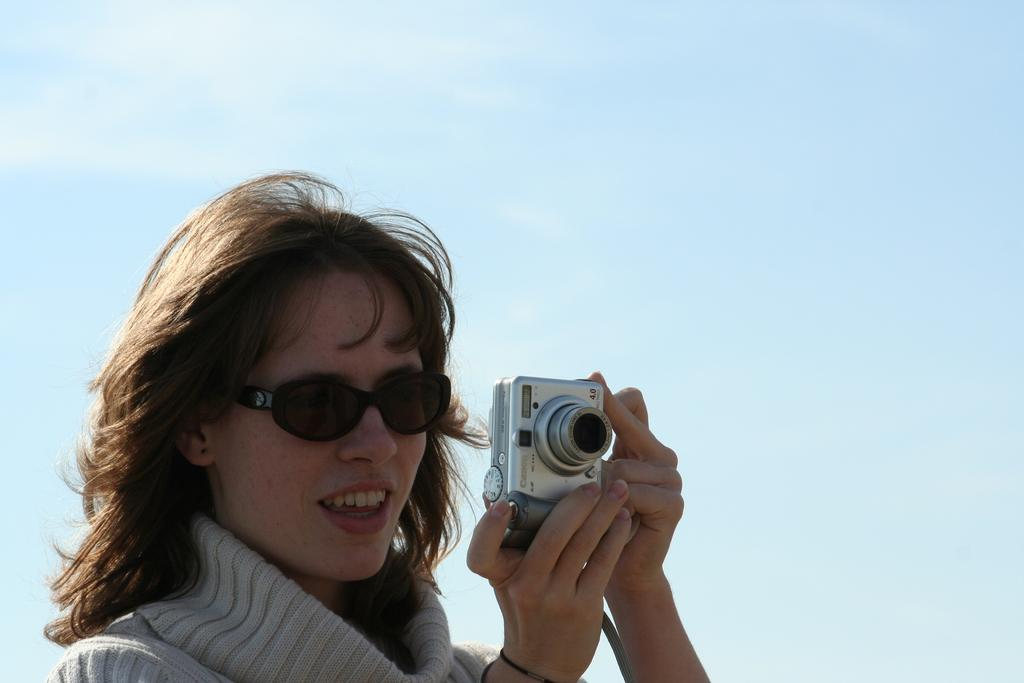Who is the main subject in the image? There is a woman in the image. What is the woman holding in the image? The woman is holding a digital camera. What is the woman doing with the digital camera? The woman is clicking a photo. What accessory is the woman wearing in the image? The woman is wearing spectacles. What can be seen in the background of the image? There is a sky visible in the background of the image. Is the woman holding an umbrella in the image? No, the woman is not holding an umbrella in the image; she is holding a digital camera. 